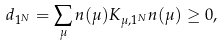Convert formula to latex. <formula><loc_0><loc_0><loc_500><loc_500>d _ { 1 ^ { N } } = \sum _ { \mu } n ( \mu ) K _ { \mu , 1 ^ { N } } n ( \mu ) \geq 0 ,</formula> 